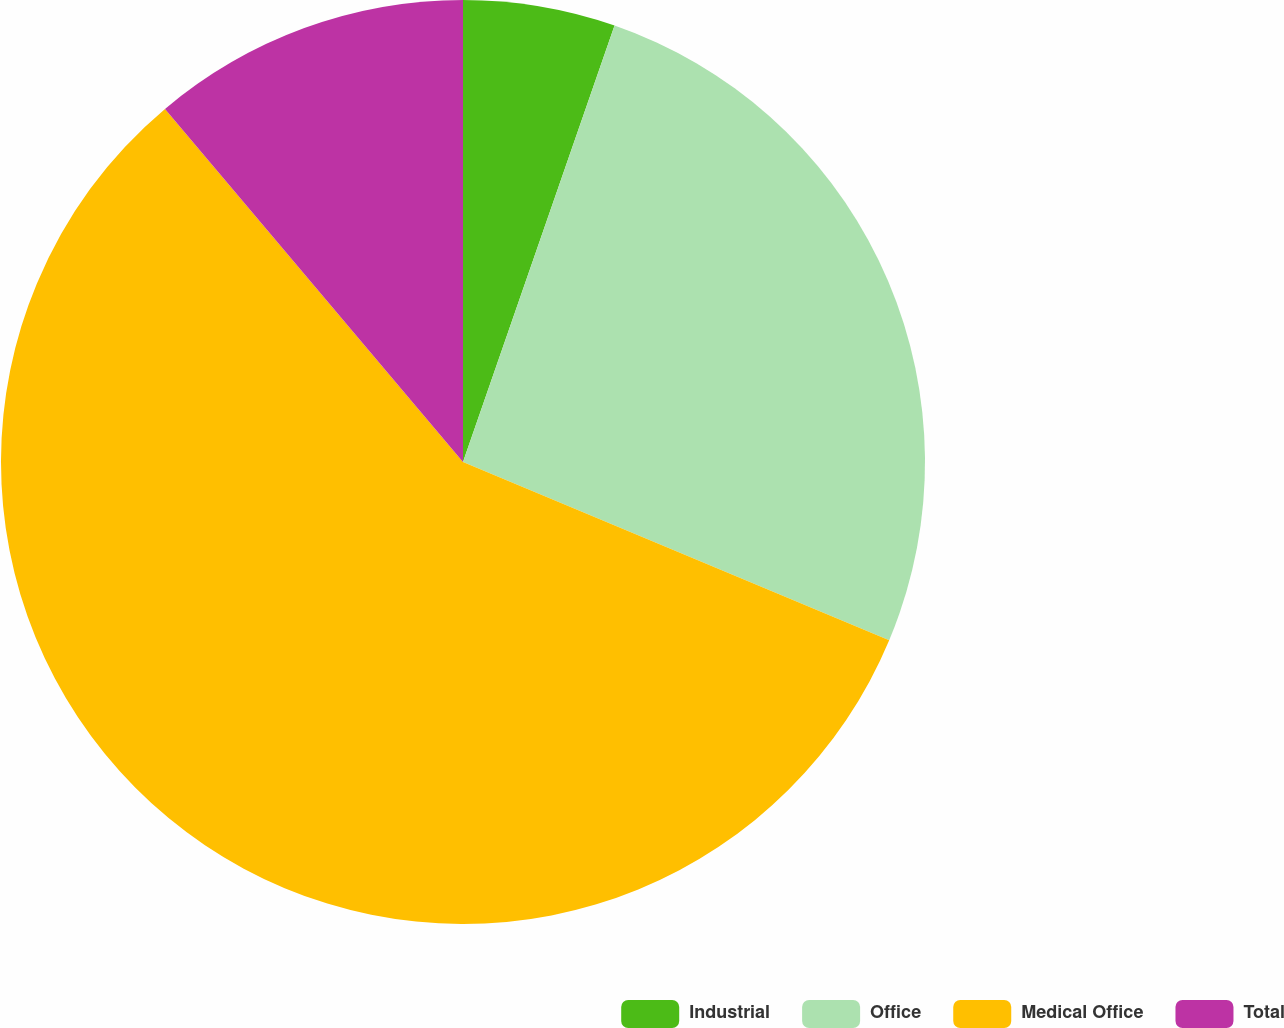Convert chart. <chart><loc_0><loc_0><loc_500><loc_500><pie_chart><fcel>Industrial<fcel>Office<fcel>Medical Office<fcel>Total<nl><fcel>5.32%<fcel>25.99%<fcel>57.54%<fcel>11.16%<nl></chart> 